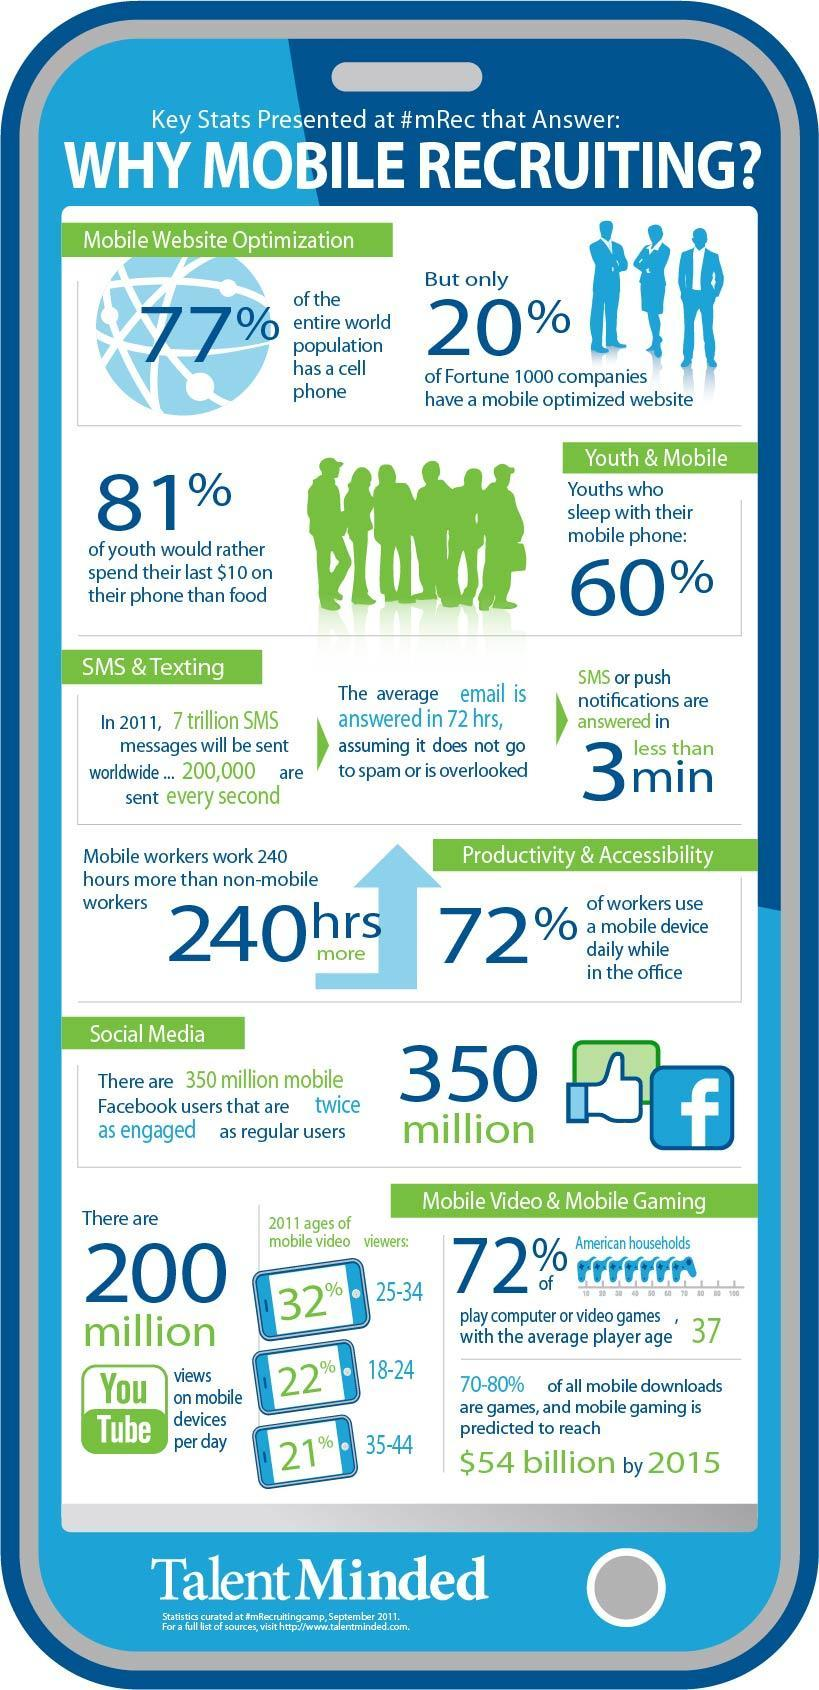What percentage of workers do not use mobile device while in the office in 2011?
Answer the question with a short phrase. 28% What percentage of entire world population don't have a mobile phone in 2011? 23% What percentage of mobile video viewers are in the age group of 25-34 in 2011? 32% What percentage of youths do not sleep with their mobile phones in 2011? 40% What percentage of mobile video viewers are in the age group of 18-24 in 2011? 22% 